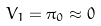Convert formula to latex. <formula><loc_0><loc_0><loc_500><loc_500>V _ { 1 } = \pi _ { 0 } \approx 0</formula> 